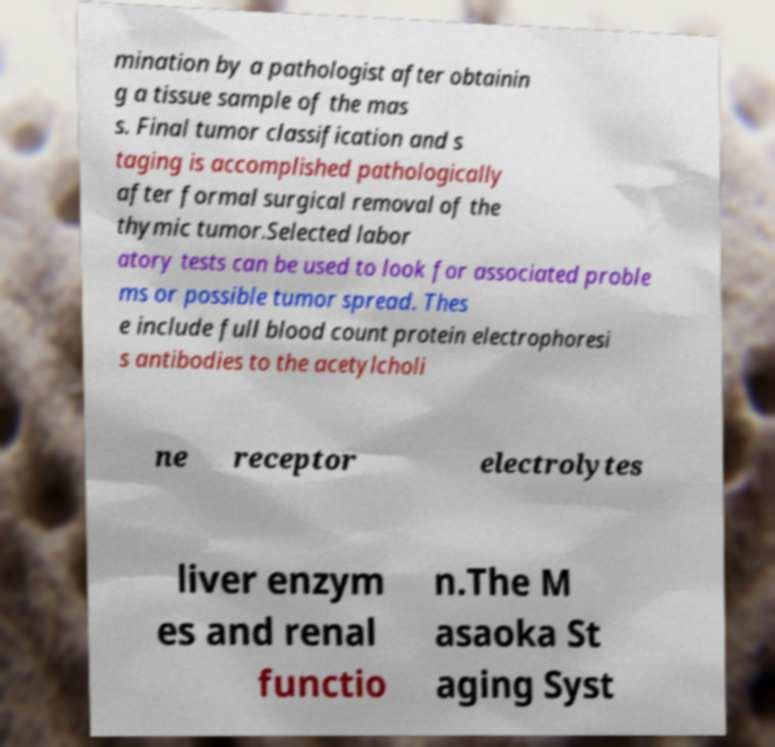Could you assist in decoding the text presented in this image and type it out clearly? mination by a pathologist after obtainin g a tissue sample of the mas s. Final tumor classification and s taging is accomplished pathologically after formal surgical removal of the thymic tumor.Selected labor atory tests can be used to look for associated proble ms or possible tumor spread. Thes e include full blood count protein electrophoresi s antibodies to the acetylcholi ne receptor electrolytes liver enzym es and renal functio n.The M asaoka St aging Syst 